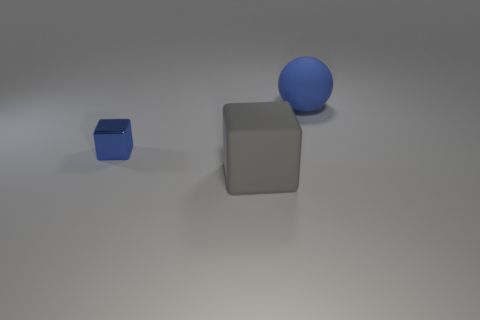Add 2 big balls. How many objects exist? 5 Subtract all balls. How many objects are left? 2 Add 3 tiny brown shiny things. How many tiny brown shiny things exist? 3 Subtract 0 purple cubes. How many objects are left? 3 Subtract all small blue things. Subtract all big matte things. How many objects are left? 0 Add 3 blue metal things. How many blue metal things are left? 4 